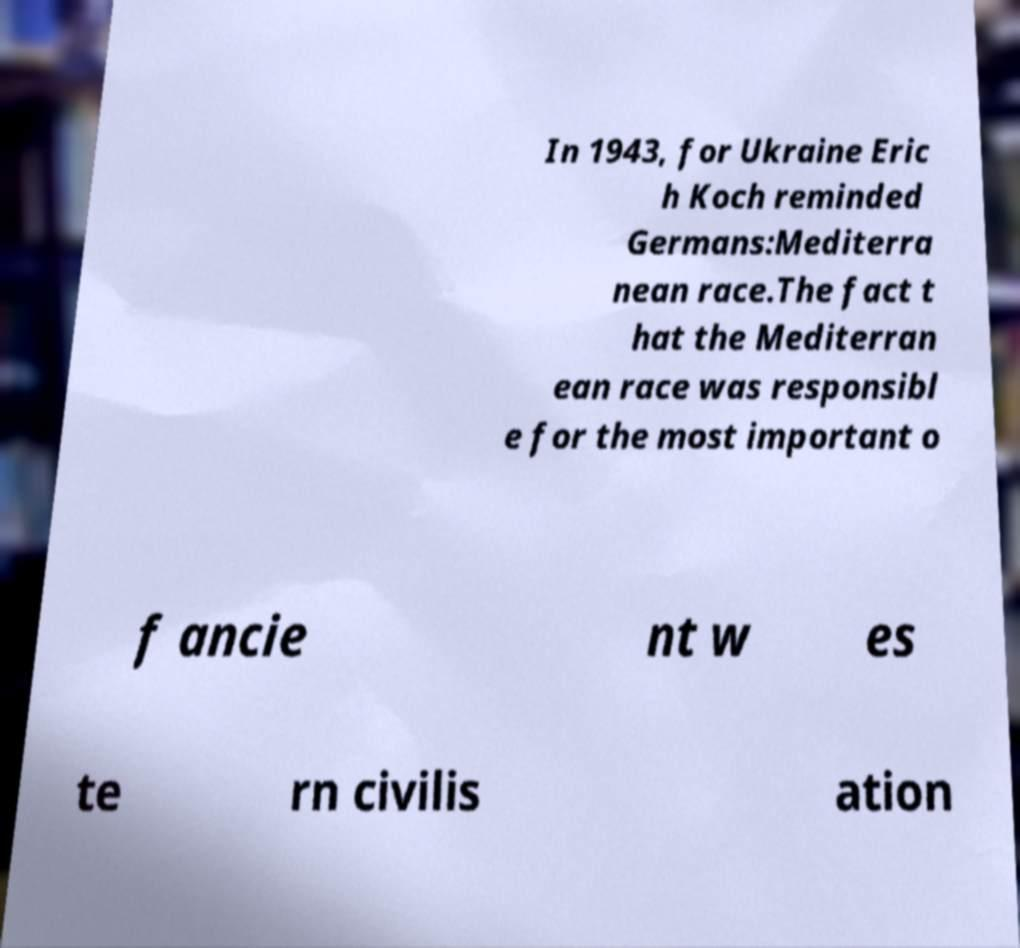I need the written content from this picture converted into text. Can you do that? In 1943, for Ukraine Eric h Koch reminded Germans:Mediterra nean race.The fact t hat the Mediterran ean race was responsibl e for the most important o f ancie nt w es te rn civilis ation 